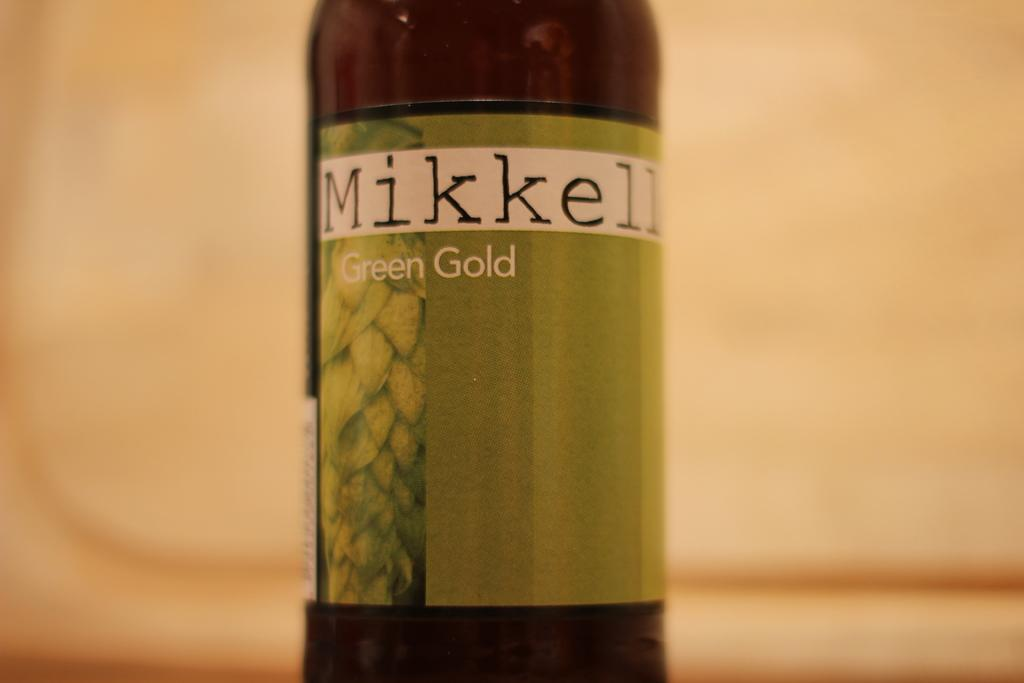<image>
Describe the image concisely. A bottle for Mikkell Green Gold beverage stands out against a creamy beige background. 